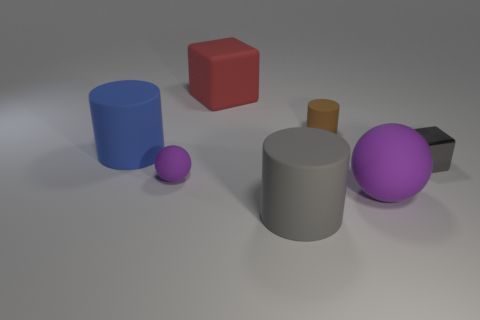There is another sphere that is the same color as the large sphere; what is its size?
Provide a succinct answer. Small. What number of big objects are brown matte objects or yellow cylinders?
Your answer should be compact. 0. Are there any other things of the same color as the large sphere?
Provide a succinct answer. Yes. There is a red cube to the left of the brown rubber cylinder that is behind the large rubber cylinder in front of the blue cylinder; what is it made of?
Your answer should be very brief. Rubber. What number of shiny things are either large gray objects or tiny cylinders?
Give a very brief answer. 0. What number of purple objects are either cubes or small rubber spheres?
Your answer should be very brief. 1. There is a large matte object to the right of the gray matte object; is its color the same as the tiny cylinder?
Ensure brevity in your answer.  No. Is the tiny ball made of the same material as the tiny cylinder?
Give a very brief answer. Yes. Are there an equal number of large cubes to the right of the small brown cylinder and brown rubber cylinders that are in front of the gray cylinder?
Provide a short and direct response. Yes. What is the material of the other object that is the same shape as the large purple rubber object?
Your answer should be compact. Rubber. 